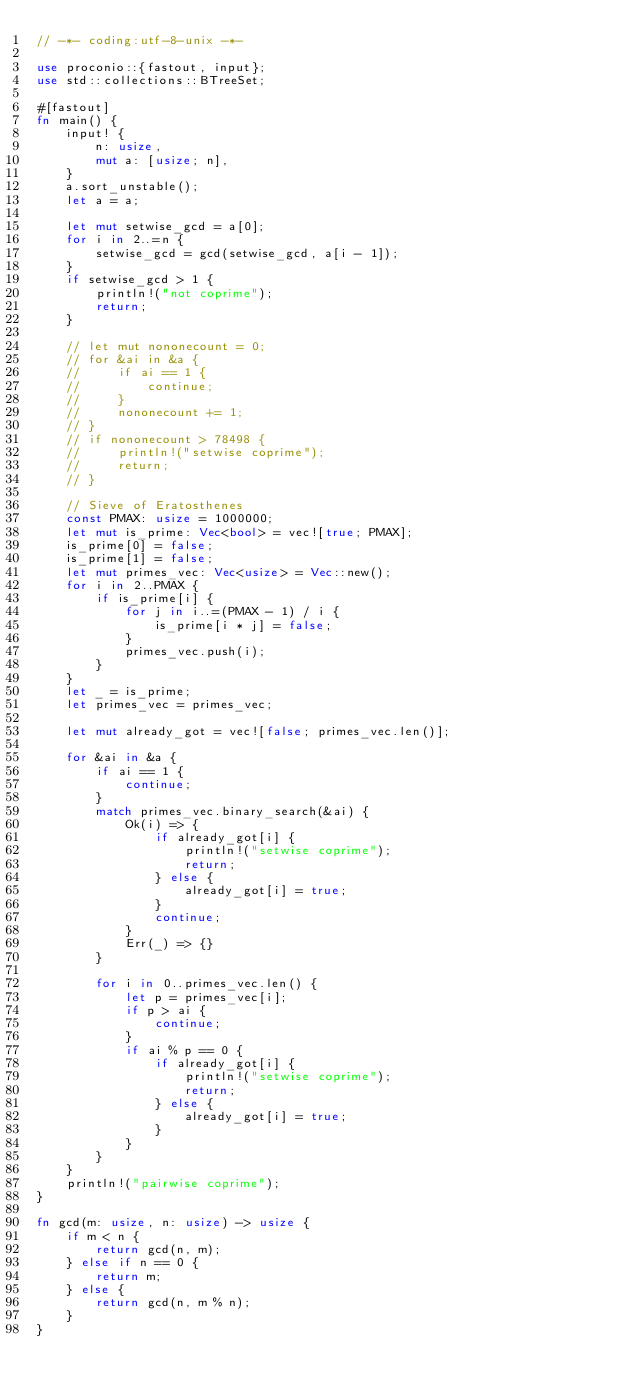<code> <loc_0><loc_0><loc_500><loc_500><_Rust_>// -*- coding:utf-8-unix -*-

use proconio::{fastout, input};
use std::collections::BTreeSet;

#[fastout]
fn main() {
    input! {
        n: usize,
        mut a: [usize; n],
    }
    a.sort_unstable();
    let a = a;

    let mut setwise_gcd = a[0];
    for i in 2..=n {
        setwise_gcd = gcd(setwise_gcd, a[i - 1]);
    }
    if setwise_gcd > 1 {
        println!("not coprime");
        return;
    }

    // let mut nononecount = 0;
    // for &ai in &a {
    //     if ai == 1 {
    //         continue;
    //     }
    //     nononecount += 1;
    // }
    // if nononecount > 78498 {
    //     println!("setwise coprime");
    //     return;
    // }

    // Sieve of Eratosthenes
    const PMAX: usize = 1000000;
    let mut is_prime: Vec<bool> = vec![true; PMAX];
    is_prime[0] = false;
    is_prime[1] = false;
    let mut primes_vec: Vec<usize> = Vec::new();
    for i in 2..PMAX {
        if is_prime[i] {
            for j in i..=(PMAX - 1) / i {
                is_prime[i * j] = false;
            }
            primes_vec.push(i);
        }
    }
    let _ = is_prime;
    let primes_vec = primes_vec;

    let mut already_got = vec![false; primes_vec.len()];

    for &ai in &a {
        if ai == 1 {
            continue;
        }
        match primes_vec.binary_search(&ai) {
            Ok(i) => {
                if already_got[i] {
                    println!("setwise coprime");
                    return;
                } else {
                    already_got[i] = true;
                }
                continue;
            }
            Err(_) => {}
        }

        for i in 0..primes_vec.len() {
            let p = primes_vec[i];
            if p > ai {
                continue;
            }
            if ai % p == 0 {
                if already_got[i] {
                    println!("setwise coprime");
                    return;
                } else {
                    already_got[i] = true;
                }
            }
        }
    }
    println!("pairwise coprime");
}

fn gcd(m: usize, n: usize) -> usize {
    if m < n {
        return gcd(n, m);
    } else if n == 0 {
        return m;
    } else {
        return gcd(n, m % n);
    }
}
</code> 